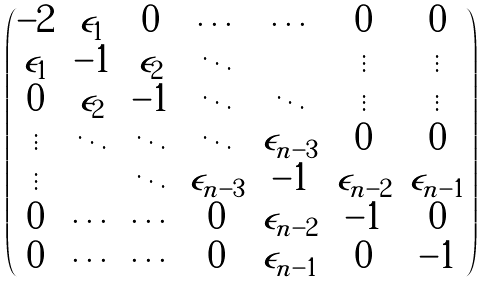Convert formula to latex. <formula><loc_0><loc_0><loc_500><loc_500>\begin{pmatrix} - 2 & \epsilon _ { 1 } & 0 & \cdots & \cdots & 0 & 0 \\ \epsilon _ { 1 } & - 1 & \epsilon _ { 2 } & \ddots & & \vdots & \vdots \\ 0 & \epsilon _ { 2 } & - 1 & \ddots & \ddots & \vdots & \vdots \\ \vdots & \ddots & \ddots & \ddots & \epsilon _ { n - 3 } & 0 & 0 \\ \vdots & & \ddots & \epsilon _ { n - 3 } & - 1 & \epsilon _ { n - 2 } & \epsilon _ { n - 1 } \\ 0 & \cdots & \cdots & 0 & \epsilon _ { n - 2 } & - 1 & 0 \\ 0 & \cdots & \cdots & 0 & \epsilon _ { n - 1 } & 0 & - 1 \\ \end{pmatrix}</formula> 